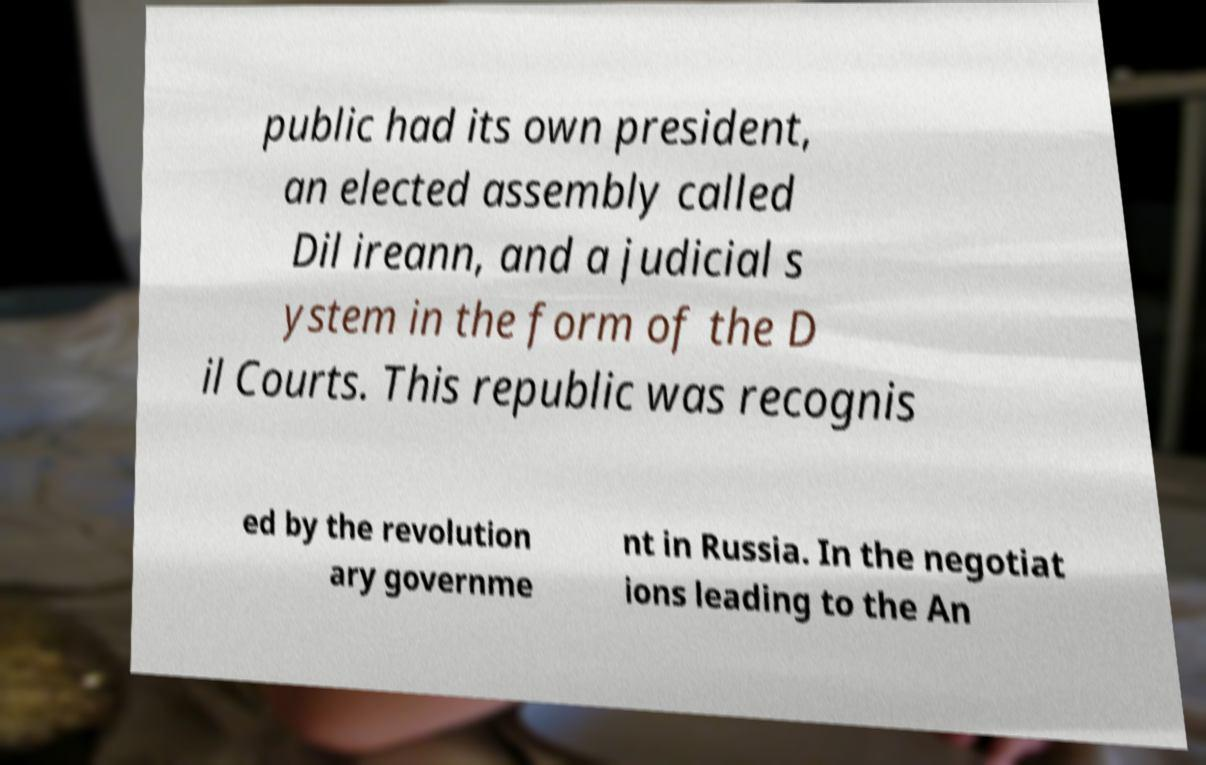Could you extract and type out the text from this image? public had its own president, an elected assembly called Dil ireann, and a judicial s ystem in the form of the D il Courts. This republic was recognis ed by the revolution ary governme nt in Russia. In the negotiat ions leading to the An 